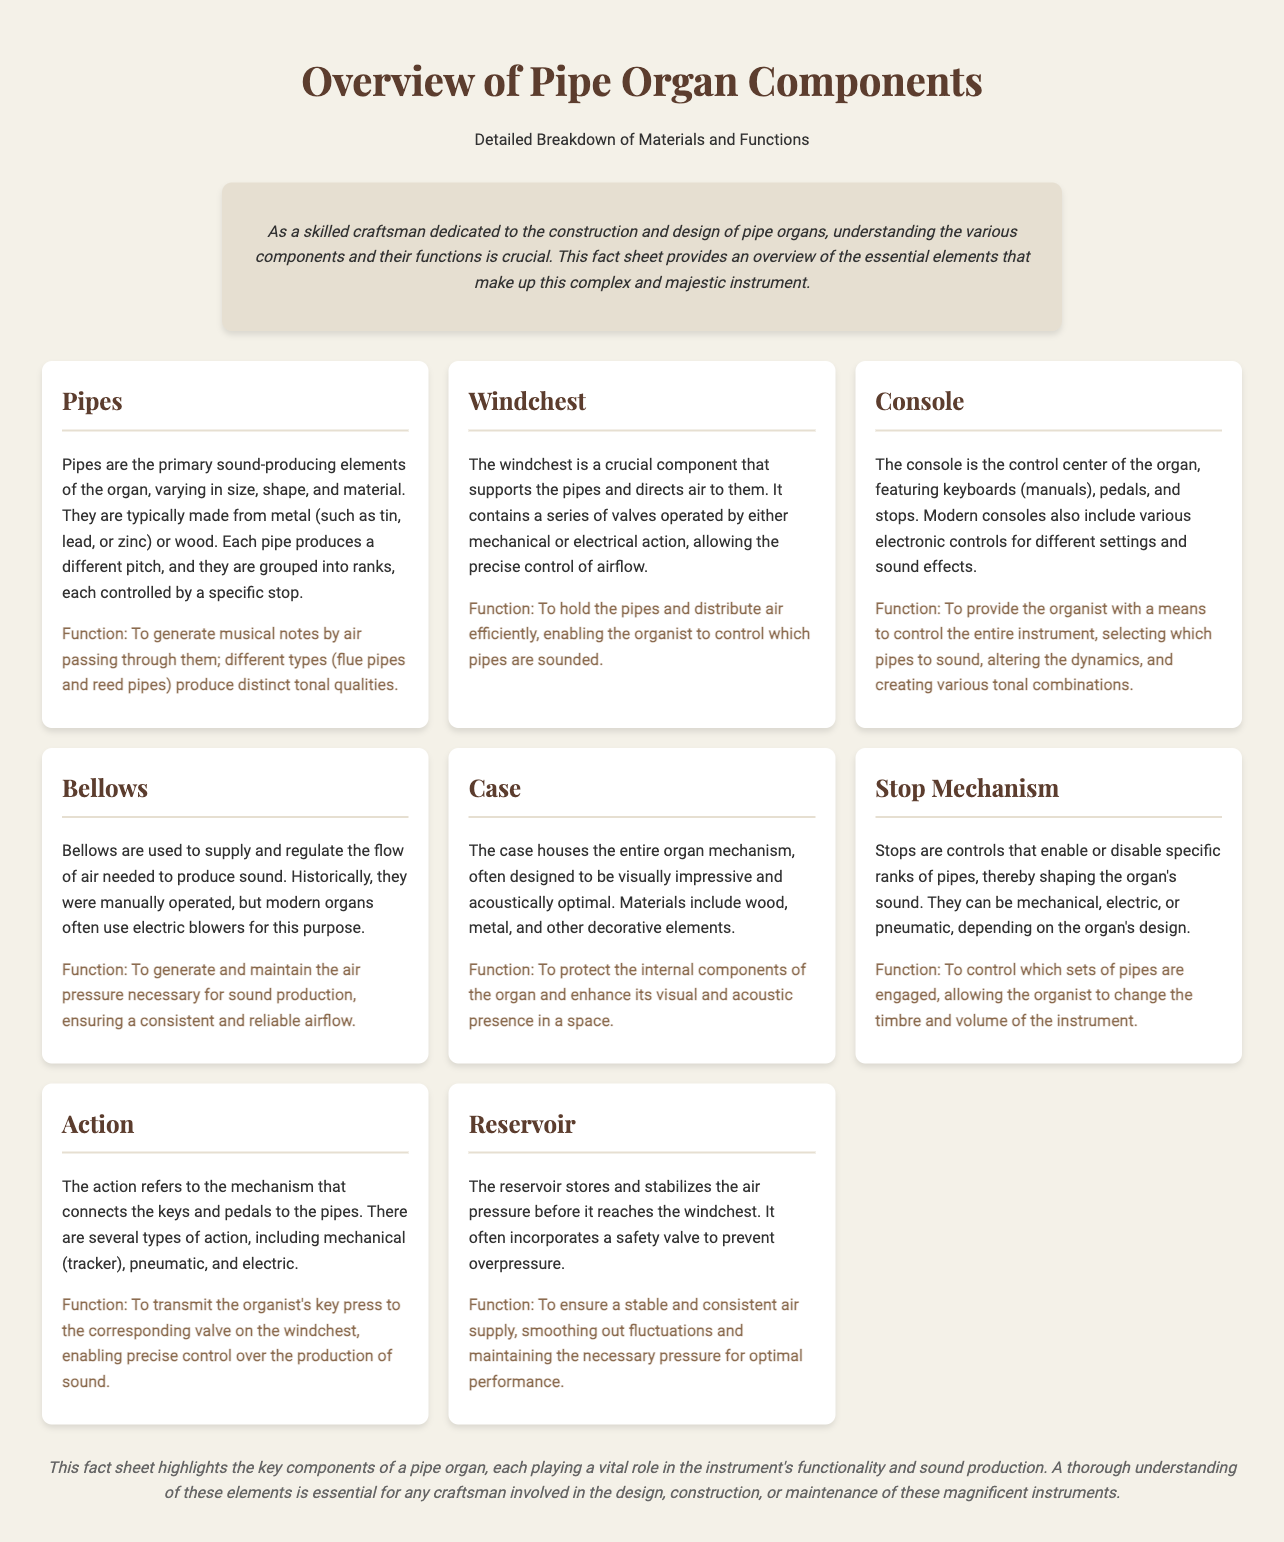What are the primary sound-producing elements of the organ? The document specifies that pipes are the primary sound-producing elements of the organ.
Answer: Pipes What materials are commonly used to make pipes? The document mentions that pipes are typically made from metal (tin, lead, or zinc) or wood.
Answer: Metal or wood What component supports the pipes and directs air to them? The document states that the windchest is the component that supports the pipes and directs air.
Answer: Windchest Which part serves as the control center of the organ? According to the document, the console is the control center of the organ.
Answer: Console What is the function of the bellows? The document explains that the bellows generate and maintain the air pressure necessary for sound production.
Answer: Generate air pressure What does the stop mechanism control? The document explains that the stop mechanism controls which sets of pipes are engaged.
Answer: Sets of pipes How does the action relate to sound production? The document states that the action transmits the organist's key press to the corresponding valve on the windchest.
Answer: Transmits key press What is the role of the reservoir in the organ? The document specifies that the reservoir ensures a stable and consistent air supply.
Answer: Stable air supply 